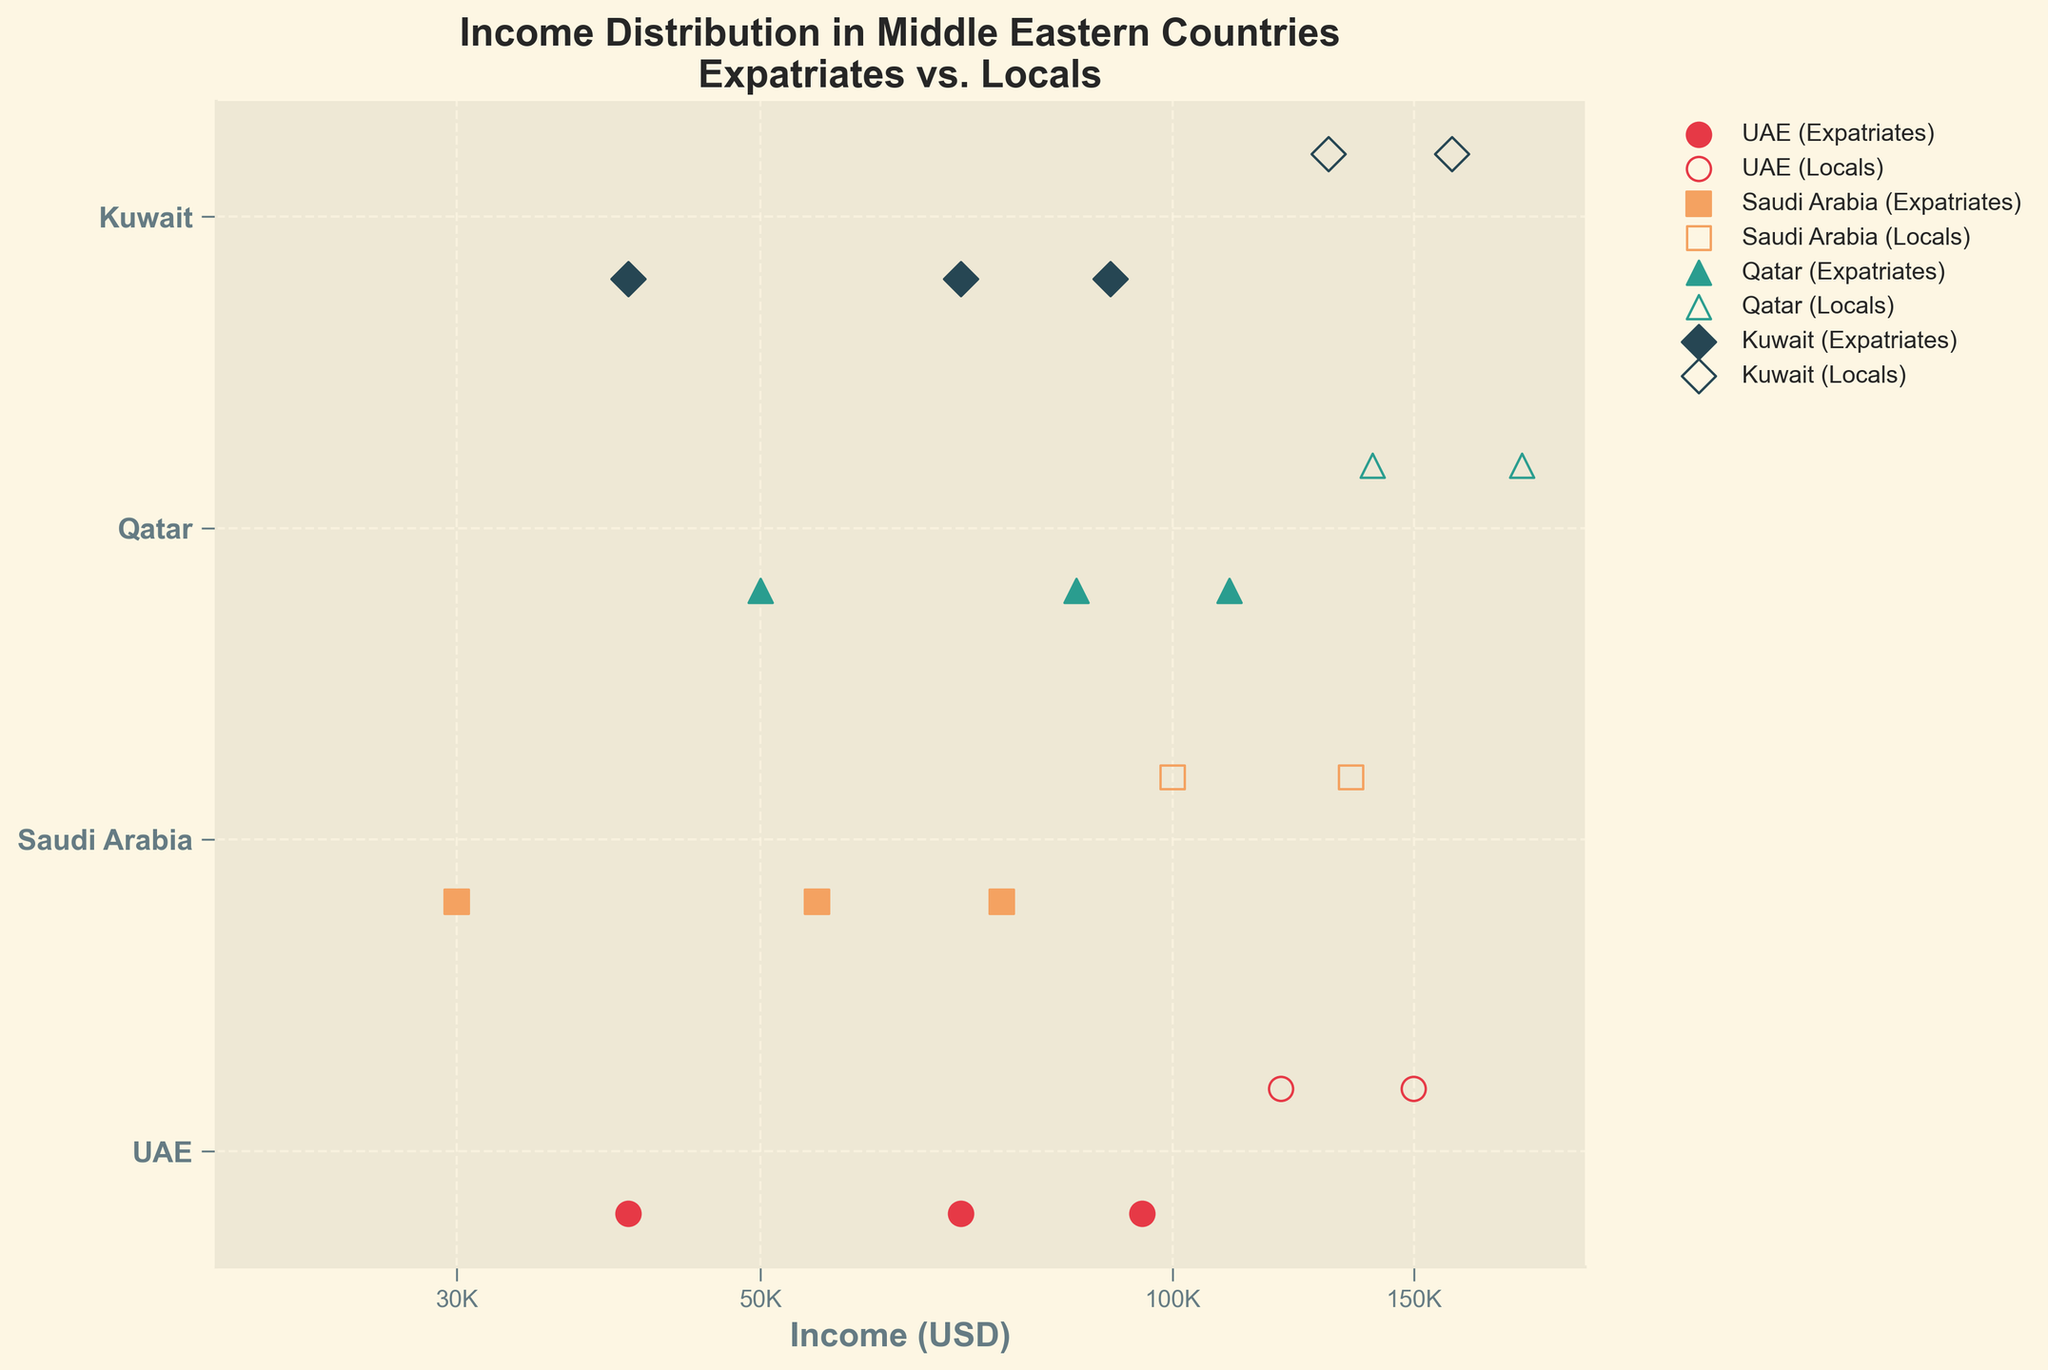What are the countries included in the income distribution figure? The figure includes four countries: UAE, Saudi Arabia, Qatar, and Kuwait. The names of these countries are labeled on the y-axis.
Answer: UAE, Saudi Arabia, Qatar, Kuwait What is the lowest income value for expatriates in the UAE? On the log-scaled x-axis, the lowest income value for expatriates in the UAE can be found at $40,000. It is represented by a marker near the UAE label on the y-axis.
Answer: $40,000 How does the income distribution between expatriates and locals in Saudi Arabia compare? The marker positions indicate that expatriates in Saudi Arabia have incomes around $30,000, $55,000, and $75,000, while locals have incomes around $100,000 and $135,000. Locals have consistently higher incomes than expatriates in Saudi Arabia.
Answer: Locals have higher incomes What is the range of incomes for locals in Qatar according to the plot? The local incomes in Qatar range from $140,000 to $180,000 as seen on the log-scaled x-axis from the markers clustered around these values near the Qatar label on the y-axis.
Answer: $140,000 to $180,000 Which country shows the largest income difference between expatriates and locals? By examining the widest gap in income between expatriates and locals in each country, Qatar shows the largest income difference. Expatriate incomes range from $50,000 to $110,000 while local incomes range from $140,000 to $180,000.
Answer: Qatar What is the average income of expatriates in Kuwait? The incomes for expatriates in Kuwait are $40,000, $70,000, and $90,000. To find the average, we sum these values and divide by 3. ($40,000 + $70,000 + $90,000) / 3 = $200,000 / 3 ≈ $66,667
Answer: $66,667 Are there any countries where the incomes of expatriates are higher than some locals? In the UAE, the highest income for expatriates is $95,000, which is lower than the lowest income for locals at $120,000. In Saudi Arabia, Qatar, and Kuwait, expatriate incomes do not surpass local incomes either.
Answer: No Which group has the most clustered income values in Saudi Arabia? The expatriates in Saudi Arabia have three income values ($30,000, $55,000, and $75,000) that are more spread out compared to the locals who have two closer values ($100,000 and $135,000). Therefore, the incomes for locals are more clustered.
Answer: Locals 